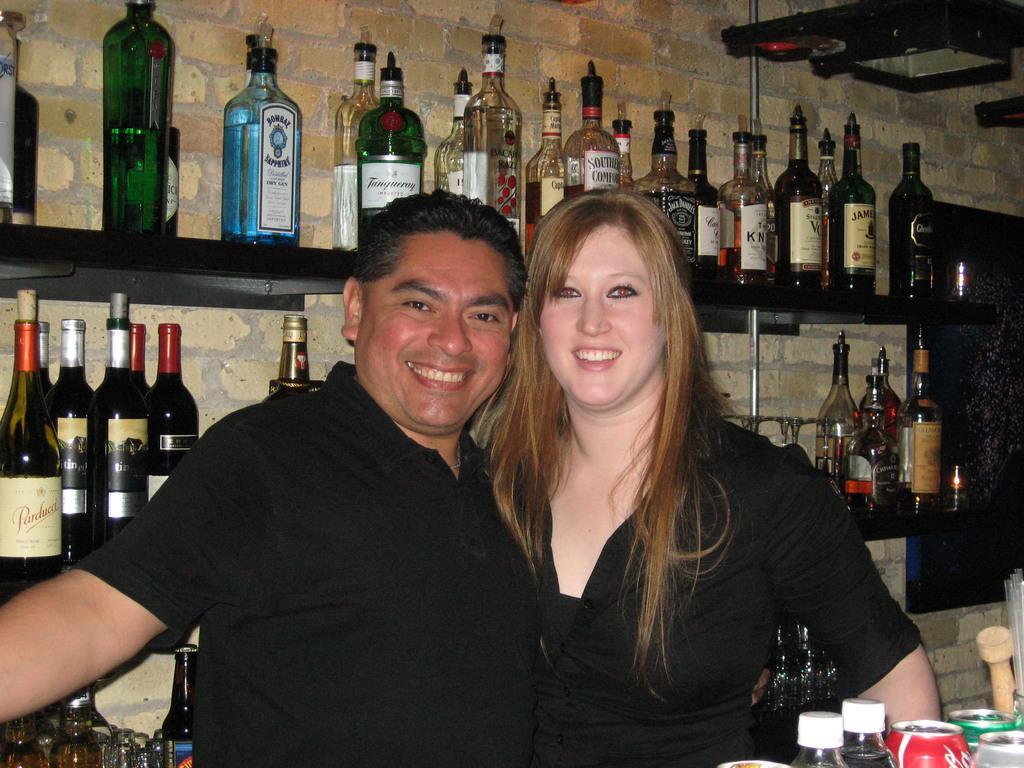In one or two sentences, can you explain what this image depicts? On the background we can see wall with bricks. We can see all the bottles arranged in a sequence manner in racks. We can see a woman and a man wearing black t shirts , they are together side by side and they are carrying beautiful smile on their faces. In Front portion of the picture we can see bottles, tins. 